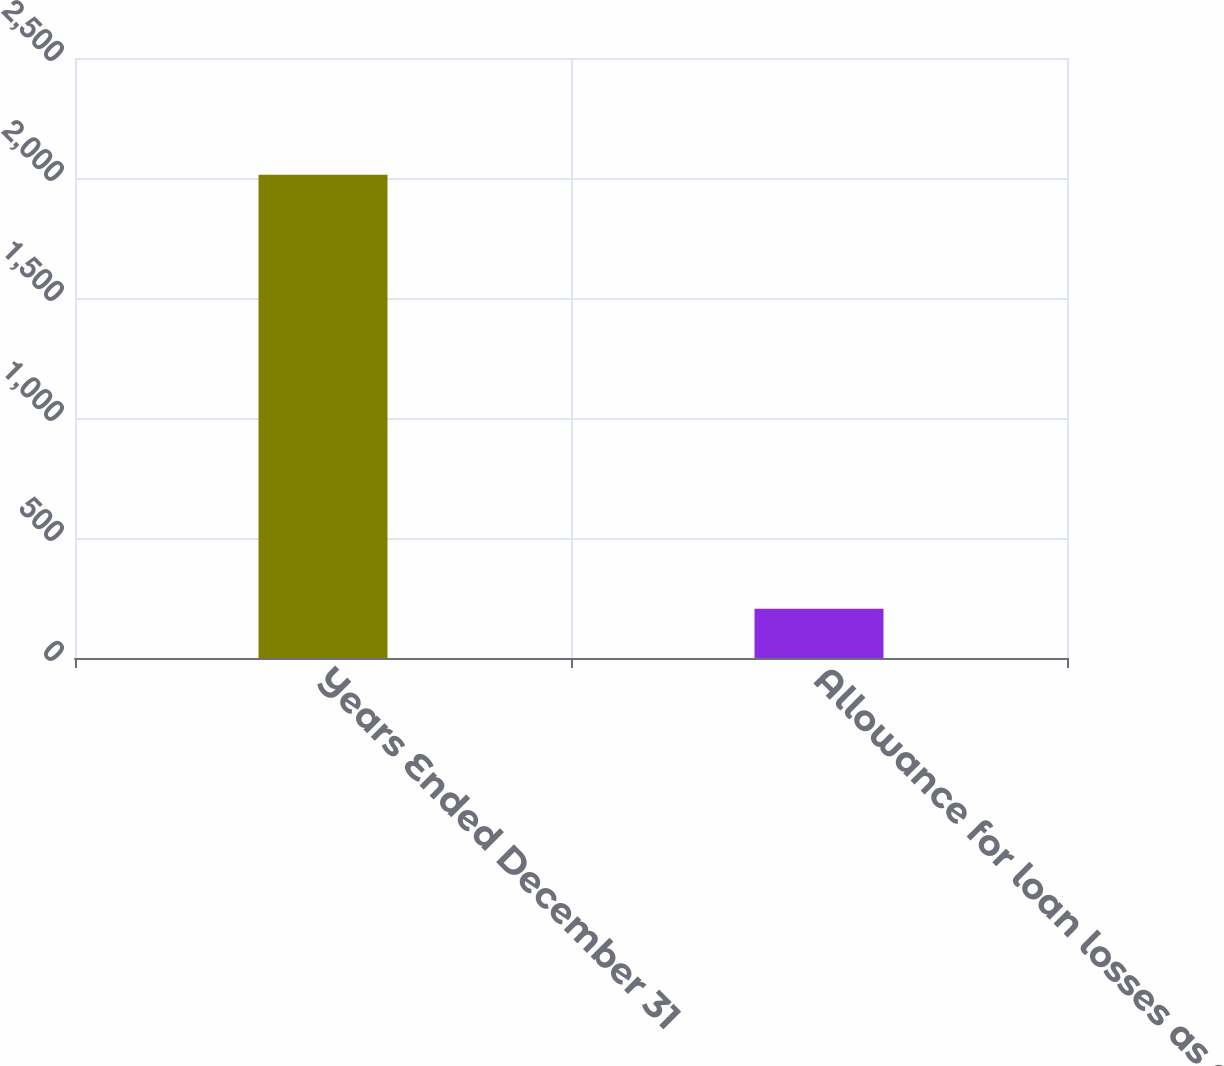<chart> <loc_0><loc_0><loc_500><loc_500><bar_chart><fcel>Years Ended December 31<fcel>Allowance for loan losses as a<nl><fcel>2014<fcel>205<nl></chart> 